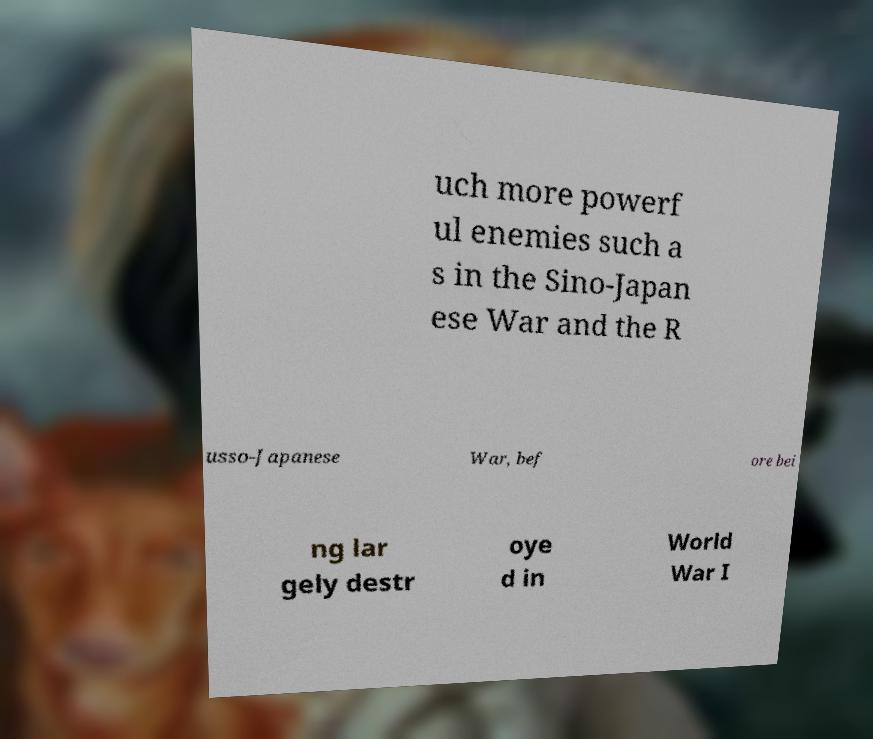Could you assist in decoding the text presented in this image and type it out clearly? uch more powerf ul enemies such a s in the Sino-Japan ese War and the R usso-Japanese War, bef ore bei ng lar gely destr oye d in World War I 